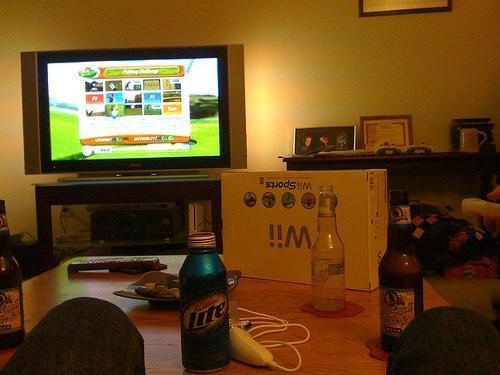How many knees can be seen?
Give a very brief answer. 2. 